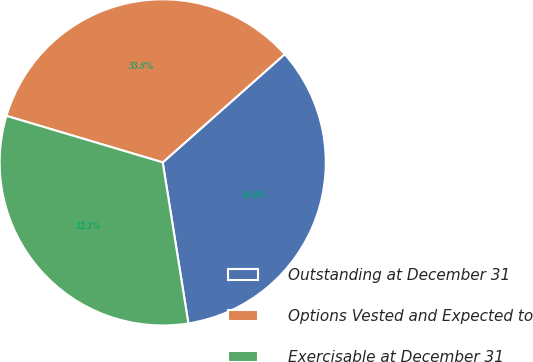Convert chart. <chart><loc_0><loc_0><loc_500><loc_500><pie_chart><fcel>Outstanding at December 31<fcel>Options Vested and Expected to<fcel>Exercisable at December 31<nl><fcel>34.03%<fcel>33.85%<fcel>32.12%<nl></chart> 